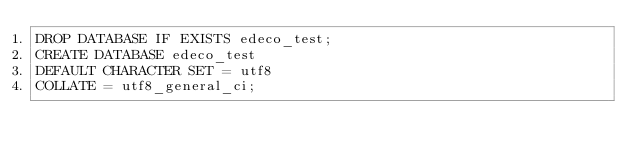Convert code to text. <code><loc_0><loc_0><loc_500><loc_500><_SQL_>DROP DATABASE IF EXISTS edeco_test;
CREATE DATABASE edeco_test 
DEFAULT CHARACTER SET = utf8
COLLATE = utf8_general_ci;</code> 